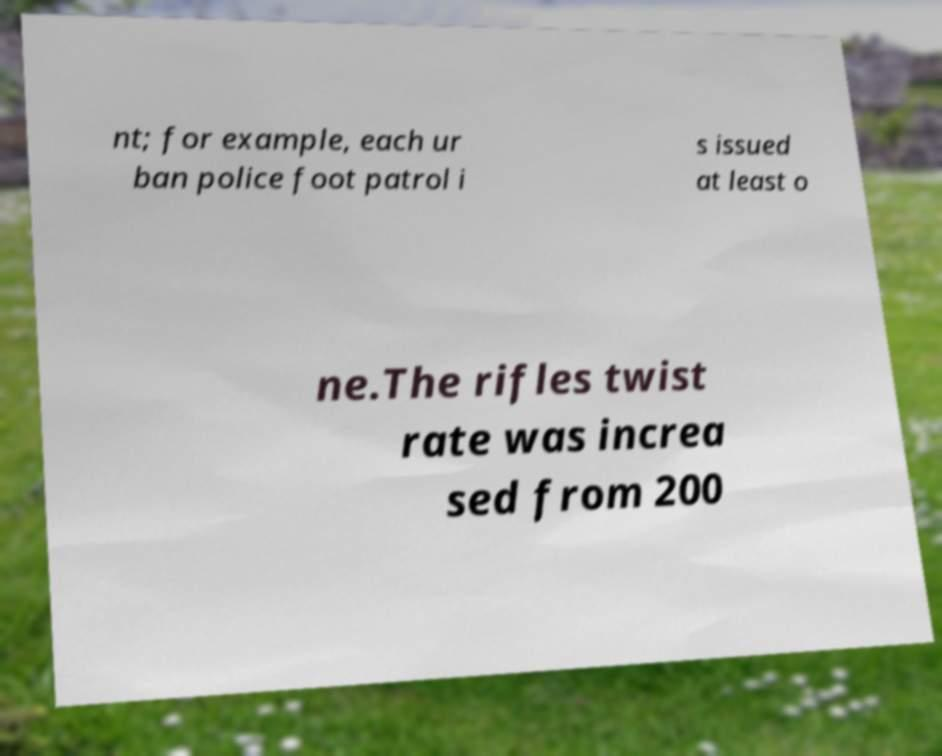Can you accurately transcribe the text from the provided image for me? nt; for example, each ur ban police foot patrol i s issued at least o ne.The rifles twist rate was increa sed from 200 